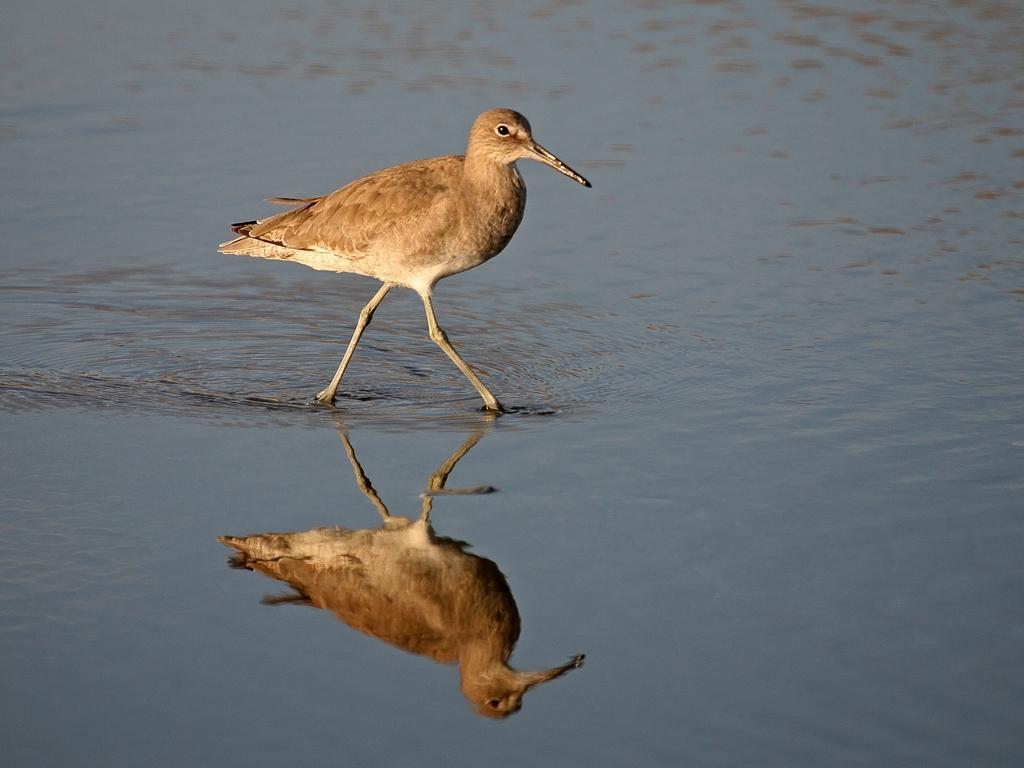Describe this image in one or two sentences. In this picture we can see a bird standing in the water. On the water, we can see the reflection of the bird. 